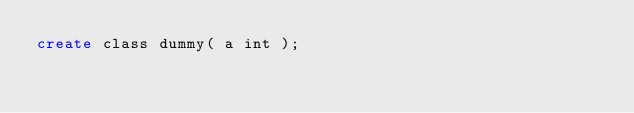Convert code to text. <code><loc_0><loc_0><loc_500><loc_500><_SQL_>create class dummy( a int );</code> 